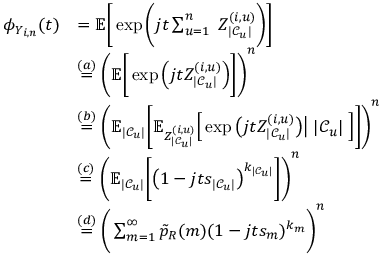<formula> <loc_0><loc_0><loc_500><loc_500>\begin{array} { r l } { \phi _ { Y _ { i , n } } ( t ) } & { = \mathbb { E } \Big [ \exp \Big ( j t \sum _ { u = 1 } ^ { n } \, Z _ { | \mathcal { C } _ { u } | } ^ { ( i , u ) } \Big ) \Big ] } \\ & { \stackrel { ( a ) } { = } \Big ( \mathbb { E } \Big [ \exp \Big ( j t Z _ { | \mathcal { C } _ { u } | } ^ { ( i , u ) } \Big ) \Big ] \Big ) ^ { n } } \\ & { \stackrel { ( b ) } { = } \Big ( \mathbb { E } _ { | \mathcal { C } _ { u } | } \Big [ \mathbb { E } _ { Z _ { | \mathcal { C } _ { u } | } ^ { ( i , u ) } } \Big [ \exp \Big ( j t Z _ { | \mathcal { C } _ { u } | } ^ { ( i , u ) } \Big ) \Big | \, | \mathcal { C } _ { u } | \, \Big ] \Big ] \Big ) ^ { n } } \\ & { \stackrel { ( c ) } { = } \Big ( \mathbb { E } _ { | \mathcal { C } _ { u } | } \Big [ \Big ( 1 - j t s _ { | \mathcal { C } _ { u } | } \Big ) ^ { k _ { | \mathcal { C } _ { u } | } } \Big ] \Big ) ^ { n } } \\ & { \stackrel { ( d ) } { = } \Big ( \sum _ { m = 1 } ^ { \infty } \tilde { p } _ { R } ( m ) ( 1 - j t s _ { m } ) ^ { k _ { m } } \Big ) ^ { n } } \end{array}</formula> 